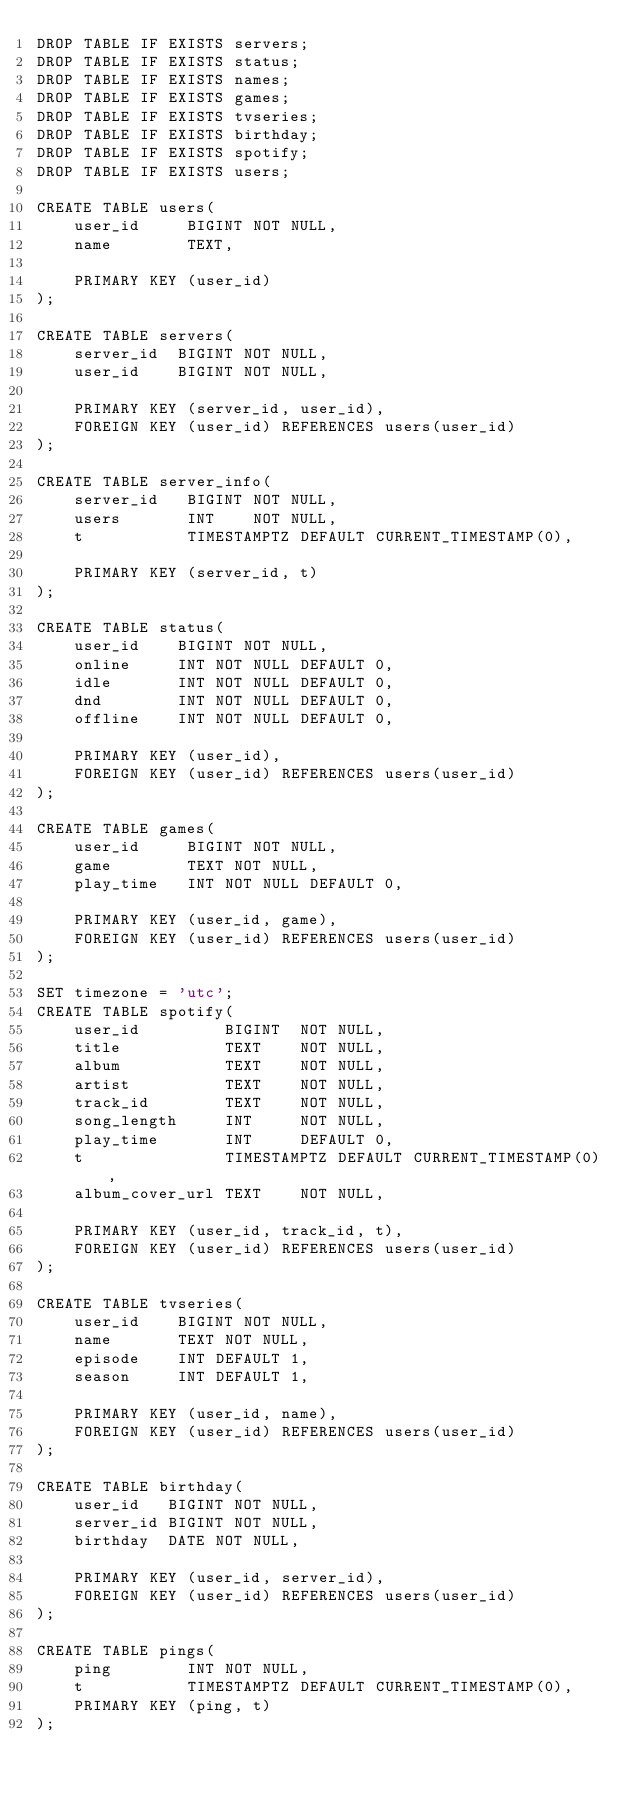<code> <loc_0><loc_0><loc_500><loc_500><_SQL_>DROP TABLE IF EXISTS servers;
DROP TABLE IF EXISTS status;
DROP TABLE IF EXISTS names;
DROP TABLE IF EXISTS games;
DROP TABLE IF EXISTS tvseries;
DROP TABLE IF EXISTS birthday;
DROP TABLE IF EXISTS spotify;
DROP TABLE IF EXISTS users;

CREATE TABLE users(
    user_id     BIGINT NOT NULL,
    name        TEXT,

    PRIMARY KEY (user_id)
);

CREATE TABLE servers(
    server_id  BIGINT NOT NULL,
    user_id    BIGINT NOT NULL,

    PRIMARY KEY (server_id, user_id),
    FOREIGN KEY (user_id) REFERENCES users(user_id)
);

CREATE TABLE server_info(
    server_id   BIGINT NOT NULL,
    users       INT    NOT NULL,
    t           TIMESTAMPTZ DEFAULT CURRENT_TIMESTAMP(0),

    PRIMARY KEY (server_id, t)
);

CREATE TABLE status(
    user_id    BIGINT NOT NULL,
    online     INT NOT NULL DEFAULT 0,
    idle       INT NOT NULL DEFAULT 0,
    dnd        INT NOT NULL DEFAULT 0,
    offline    INT NOT NULL DEFAULT 0,

    PRIMARY KEY (user_id),
    FOREIGN KEY (user_id) REFERENCES users(user_id)
);

CREATE TABLE games(
    user_id     BIGINT NOT NULL,
    game        TEXT NOT NULL,
    play_time   INT NOT NULL DEFAULT 0,

    PRIMARY KEY (user_id, game),
    FOREIGN KEY (user_id) REFERENCES users(user_id)
);

SET timezone = 'utc';
CREATE TABLE spotify(
    user_id         BIGINT  NOT NULL,
    title           TEXT    NOT NULL,
    album           TEXT    NOT NULL,
    artist          TEXT    NOT NULL,
    track_id        TEXT    NOT NULL,
    song_length     INT     NOT NULL,
    play_time       INT     DEFAULT 0,
    t               TIMESTAMPTZ DEFAULT CURRENT_TIMESTAMP(0),
    album_cover_url TEXT    NOT NULL,

    PRIMARY KEY (user_id, track_id, t),
    FOREIGN KEY (user_id) REFERENCES users(user_id)
);

CREATE TABLE tvseries(
    user_id    BIGINT NOT NULL,
    name       TEXT NOT NULL,
    episode    INT DEFAULT 1,
    season     INT DEFAULT 1,

    PRIMARY KEY (user_id, name),
    FOREIGN KEY (user_id) REFERENCES users(user_id)
);

CREATE TABLE birthday(
    user_id   BIGINT NOT NULL,
    server_id BIGINT NOT NULL,
    birthday  DATE NOT NULL,

    PRIMARY KEY (user_id, server_id),
    FOREIGN KEY (user_id) REFERENCES users(user_id)
); 

CREATE TABLE pings(
    ping     	INT NOT NULL,
	t          	TIMESTAMPTZ DEFAULT CURRENT_TIMESTAMP(0),
    PRIMARY KEY (ping, t)
);</code> 